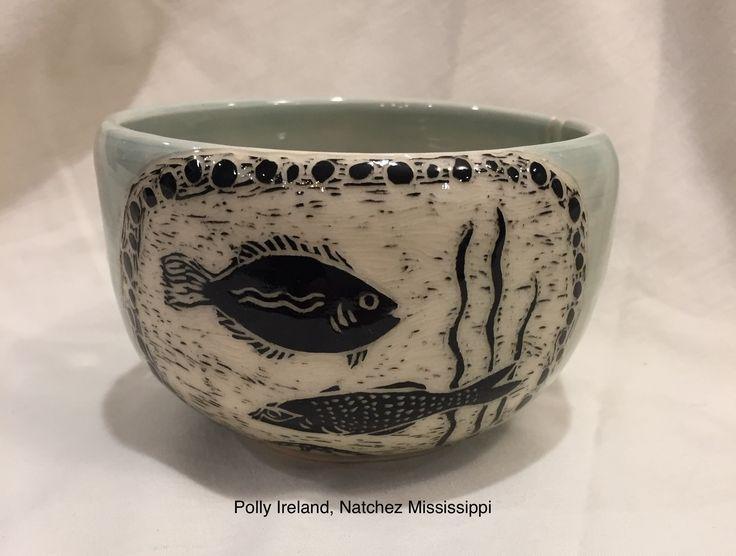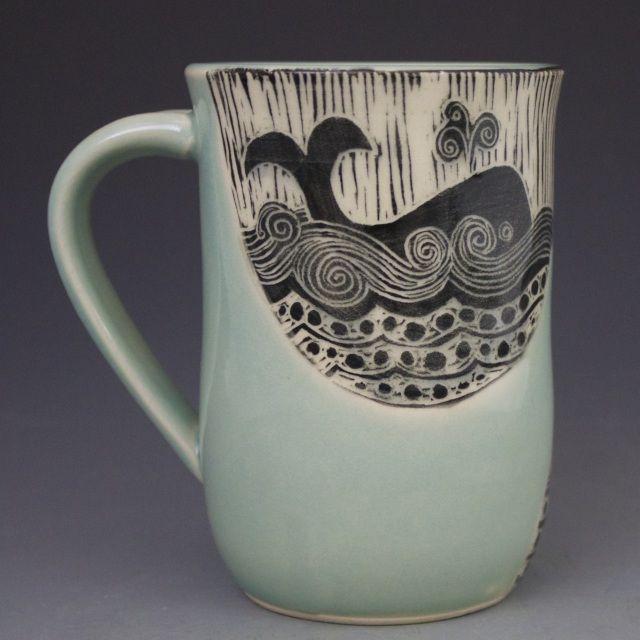The first image is the image on the left, the second image is the image on the right. Assess this claim about the two images: "The left and right image contains the same number  of cups.". Correct or not? Answer yes or no. Yes. The first image is the image on the left, the second image is the image on the right. For the images shown, is this caption "There are more than 2 cups." true? Answer yes or no. No. 